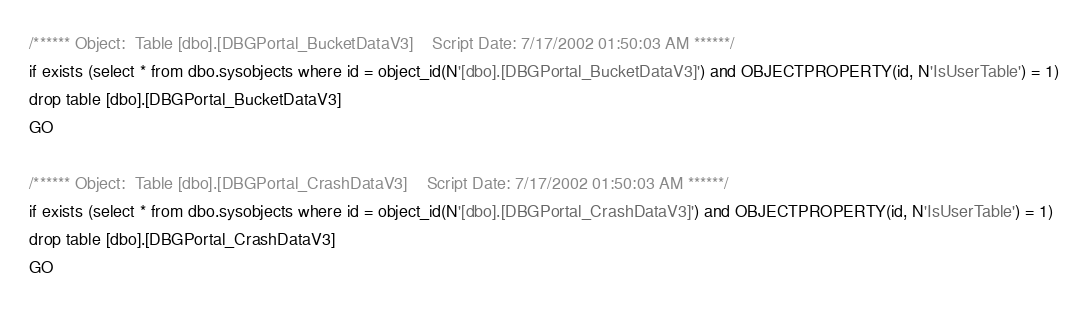Convert code to text. <code><loc_0><loc_0><loc_500><loc_500><_SQL_>/****** Object:  Table [dbo].[DBGPortal_BucketDataV3]    Script Date: 7/17/2002 01:50:03 AM ******/
if exists (select * from dbo.sysobjects where id = object_id(N'[dbo].[DBGPortal_BucketDataV3]') and OBJECTPROPERTY(id, N'IsUserTable') = 1)
drop table [dbo].[DBGPortal_BucketDataV3]
GO

/****** Object:  Table [dbo].[DBGPortal_CrashDataV3]    Script Date: 7/17/2002 01:50:03 AM ******/
if exists (select * from dbo.sysobjects where id = object_id(N'[dbo].[DBGPortal_CrashDataV3]') and OBJECTPROPERTY(id, N'IsUserTable') = 1)
drop table [dbo].[DBGPortal_CrashDataV3]
GO
</code> 